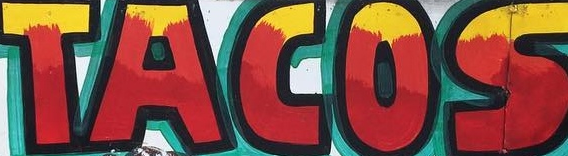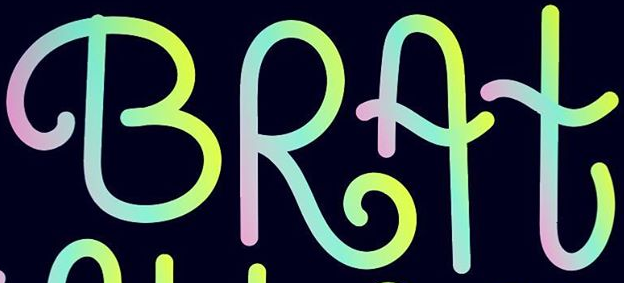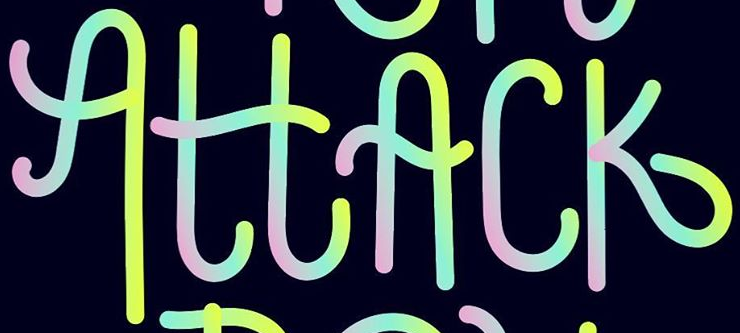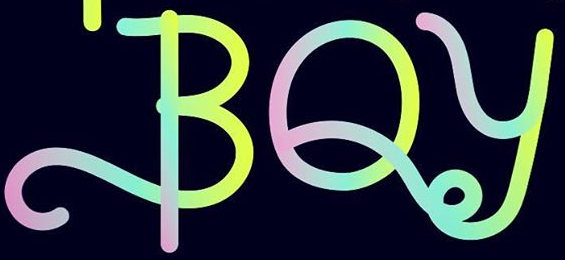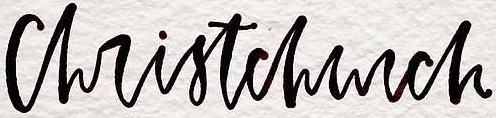What words can you see in these images in sequence, separated by a semicolon? TACOS; BRAt; AttAck; BOy; christchurch 